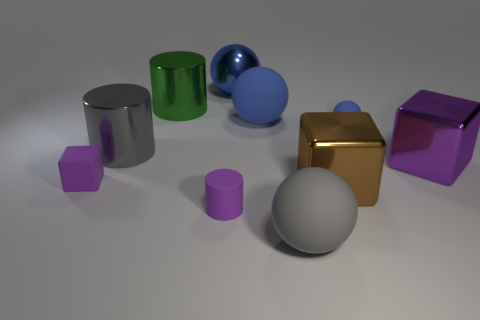Does the purple shiny thing have the same size as the brown object that is in front of the big green cylinder?
Provide a short and direct response. Yes. Are there any blue spheres?
Offer a terse response. Yes. What is the material of the big purple thing that is the same shape as the brown thing?
Provide a succinct answer. Metal. What size is the purple thing on the right side of the sphere that is left of the large matte thing behind the large gray metallic cylinder?
Ensure brevity in your answer.  Large. Are there any tiny purple rubber objects right of the green shiny cylinder?
Your answer should be very brief. Yes. What is the size of the purple cube that is the same material as the small cylinder?
Offer a terse response. Small. What number of other objects have the same shape as the large purple thing?
Ensure brevity in your answer.  2. Is the material of the small blue ball the same as the purple cube in front of the large purple metal cube?
Provide a succinct answer. Yes. Is the number of blocks that are to the left of the metallic sphere greater than the number of large green shiny blocks?
Offer a terse response. Yes. The metal object that is the same color as the tiny matte block is what shape?
Your answer should be compact. Cube. 